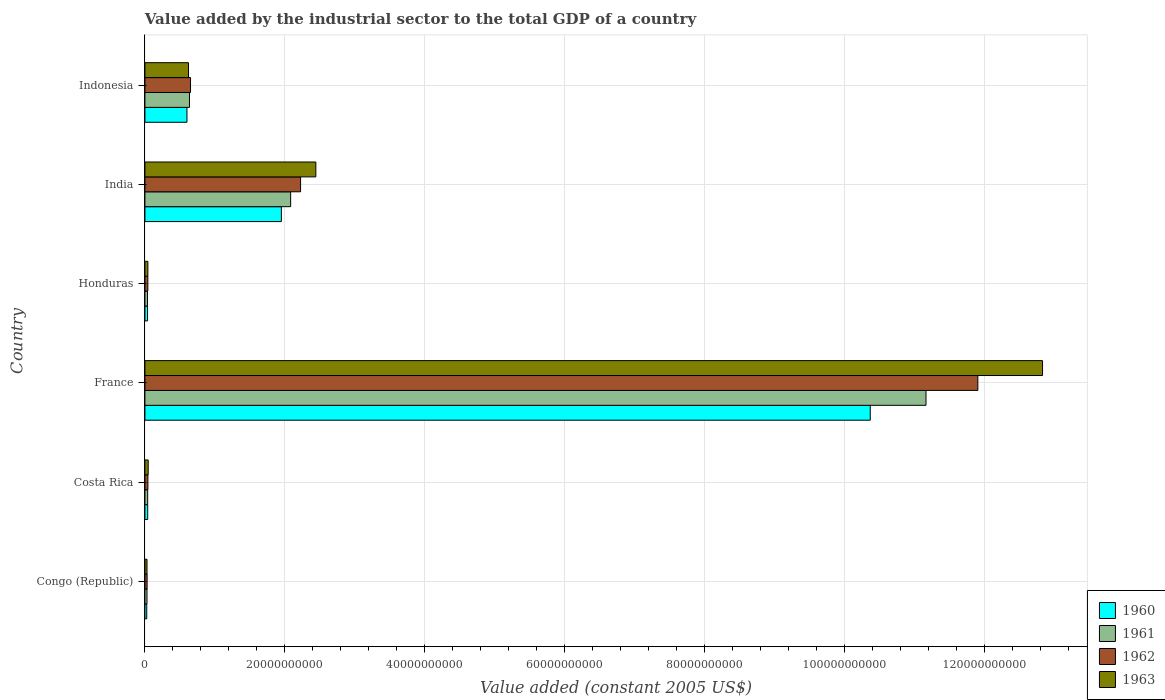How many different coloured bars are there?
Provide a succinct answer. 4. How many groups of bars are there?
Ensure brevity in your answer.  6. Are the number of bars per tick equal to the number of legend labels?
Your answer should be compact. Yes. Are the number of bars on each tick of the Y-axis equal?
Keep it short and to the point. Yes. What is the label of the 3rd group of bars from the top?
Provide a succinct answer. Honduras. What is the value added by the industrial sector in 1963 in France?
Offer a very short reply. 1.28e+11. Across all countries, what is the maximum value added by the industrial sector in 1961?
Ensure brevity in your answer.  1.12e+11. Across all countries, what is the minimum value added by the industrial sector in 1962?
Make the answer very short. 3.12e+08. In which country was the value added by the industrial sector in 1960 maximum?
Make the answer very short. France. In which country was the value added by the industrial sector in 1963 minimum?
Offer a terse response. Congo (Republic). What is the total value added by the industrial sector in 1960 in the graph?
Keep it short and to the point. 1.30e+11. What is the difference between the value added by the industrial sector in 1963 in India and that in Indonesia?
Provide a short and direct response. 1.82e+1. What is the difference between the value added by the industrial sector in 1961 in France and the value added by the industrial sector in 1960 in Indonesia?
Your answer should be very brief. 1.06e+11. What is the average value added by the industrial sector in 1962 per country?
Provide a short and direct response. 2.48e+1. What is the difference between the value added by the industrial sector in 1961 and value added by the industrial sector in 1962 in Honduras?
Provide a succinct answer. -5.00e+07. In how many countries, is the value added by the industrial sector in 1962 greater than 36000000000 US$?
Give a very brief answer. 1. What is the ratio of the value added by the industrial sector in 1963 in Congo (Republic) to that in Honduras?
Provide a short and direct response. 0.71. Is the value added by the industrial sector in 1962 in Congo (Republic) less than that in Costa Rica?
Make the answer very short. Yes. What is the difference between the highest and the second highest value added by the industrial sector in 1963?
Provide a short and direct response. 1.04e+11. What is the difference between the highest and the lowest value added by the industrial sector in 1961?
Keep it short and to the point. 1.11e+11. Is the sum of the value added by the industrial sector in 1961 in France and India greater than the maximum value added by the industrial sector in 1960 across all countries?
Your answer should be very brief. Yes. How many bars are there?
Your response must be concise. 24. How many countries are there in the graph?
Provide a short and direct response. 6. Where does the legend appear in the graph?
Your answer should be very brief. Bottom right. How many legend labels are there?
Keep it short and to the point. 4. How are the legend labels stacked?
Keep it short and to the point. Vertical. What is the title of the graph?
Your answer should be very brief. Value added by the industrial sector to the total GDP of a country. Does "1962" appear as one of the legend labels in the graph?
Your answer should be compact. Yes. What is the label or title of the X-axis?
Your answer should be compact. Value added (constant 2005 US$). What is the Value added (constant 2005 US$) of 1960 in Congo (Republic)?
Make the answer very short. 2.61e+08. What is the Value added (constant 2005 US$) of 1961 in Congo (Republic)?
Make the answer very short. 2.98e+08. What is the Value added (constant 2005 US$) in 1962 in Congo (Republic)?
Keep it short and to the point. 3.12e+08. What is the Value added (constant 2005 US$) of 1963 in Congo (Republic)?
Make the answer very short. 3.00e+08. What is the Value added (constant 2005 US$) in 1960 in Costa Rica?
Offer a very short reply. 3.98e+08. What is the Value added (constant 2005 US$) in 1961 in Costa Rica?
Your answer should be compact. 3.94e+08. What is the Value added (constant 2005 US$) in 1962 in Costa Rica?
Provide a short and direct response. 4.27e+08. What is the Value added (constant 2005 US$) in 1963 in Costa Rica?
Make the answer very short. 4.68e+08. What is the Value added (constant 2005 US$) of 1960 in France?
Offer a terse response. 1.04e+11. What is the Value added (constant 2005 US$) of 1961 in France?
Give a very brief answer. 1.12e+11. What is the Value added (constant 2005 US$) of 1962 in France?
Offer a terse response. 1.19e+11. What is the Value added (constant 2005 US$) in 1963 in France?
Keep it short and to the point. 1.28e+11. What is the Value added (constant 2005 US$) of 1960 in Honduras?
Your answer should be compact. 3.75e+08. What is the Value added (constant 2005 US$) in 1961 in Honduras?
Provide a succinct answer. 3.66e+08. What is the Value added (constant 2005 US$) in 1962 in Honduras?
Provide a succinct answer. 4.16e+08. What is the Value added (constant 2005 US$) of 1963 in Honduras?
Give a very brief answer. 4.23e+08. What is the Value added (constant 2005 US$) of 1960 in India?
Your answer should be very brief. 1.95e+1. What is the Value added (constant 2005 US$) of 1961 in India?
Ensure brevity in your answer.  2.08e+1. What is the Value added (constant 2005 US$) in 1962 in India?
Offer a terse response. 2.22e+1. What is the Value added (constant 2005 US$) of 1963 in India?
Give a very brief answer. 2.44e+1. What is the Value added (constant 2005 US$) of 1960 in Indonesia?
Provide a short and direct response. 6.01e+09. What is the Value added (constant 2005 US$) in 1961 in Indonesia?
Your response must be concise. 6.37e+09. What is the Value added (constant 2005 US$) in 1962 in Indonesia?
Make the answer very short. 6.52e+09. What is the Value added (constant 2005 US$) of 1963 in Indonesia?
Offer a terse response. 6.23e+09. Across all countries, what is the maximum Value added (constant 2005 US$) in 1960?
Keep it short and to the point. 1.04e+11. Across all countries, what is the maximum Value added (constant 2005 US$) of 1961?
Offer a very short reply. 1.12e+11. Across all countries, what is the maximum Value added (constant 2005 US$) of 1962?
Keep it short and to the point. 1.19e+11. Across all countries, what is the maximum Value added (constant 2005 US$) of 1963?
Provide a succinct answer. 1.28e+11. Across all countries, what is the minimum Value added (constant 2005 US$) in 1960?
Offer a very short reply. 2.61e+08. Across all countries, what is the minimum Value added (constant 2005 US$) of 1961?
Give a very brief answer. 2.98e+08. Across all countries, what is the minimum Value added (constant 2005 US$) in 1962?
Offer a terse response. 3.12e+08. Across all countries, what is the minimum Value added (constant 2005 US$) of 1963?
Offer a very short reply. 3.00e+08. What is the total Value added (constant 2005 US$) in 1960 in the graph?
Provide a succinct answer. 1.30e+11. What is the total Value added (constant 2005 US$) in 1961 in the graph?
Provide a short and direct response. 1.40e+11. What is the total Value added (constant 2005 US$) of 1962 in the graph?
Give a very brief answer. 1.49e+11. What is the total Value added (constant 2005 US$) of 1963 in the graph?
Offer a terse response. 1.60e+11. What is the difference between the Value added (constant 2005 US$) of 1960 in Congo (Republic) and that in Costa Rica?
Provide a short and direct response. -1.36e+08. What is the difference between the Value added (constant 2005 US$) in 1961 in Congo (Republic) and that in Costa Rica?
Your answer should be compact. -9.59e+07. What is the difference between the Value added (constant 2005 US$) of 1962 in Congo (Republic) and that in Costa Rica?
Offer a very short reply. -1.14e+08. What is the difference between the Value added (constant 2005 US$) in 1963 in Congo (Republic) and that in Costa Rica?
Provide a succinct answer. -1.68e+08. What is the difference between the Value added (constant 2005 US$) in 1960 in Congo (Republic) and that in France?
Keep it short and to the point. -1.03e+11. What is the difference between the Value added (constant 2005 US$) of 1961 in Congo (Republic) and that in France?
Give a very brief answer. -1.11e+11. What is the difference between the Value added (constant 2005 US$) in 1962 in Congo (Republic) and that in France?
Offer a terse response. -1.19e+11. What is the difference between the Value added (constant 2005 US$) in 1963 in Congo (Republic) and that in France?
Make the answer very short. -1.28e+11. What is the difference between the Value added (constant 2005 US$) in 1960 in Congo (Republic) and that in Honduras?
Your answer should be very brief. -1.14e+08. What is the difference between the Value added (constant 2005 US$) of 1961 in Congo (Republic) and that in Honduras?
Give a very brief answer. -6.81e+07. What is the difference between the Value added (constant 2005 US$) in 1962 in Congo (Republic) and that in Honduras?
Your response must be concise. -1.03e+08. What is the difference between the Value added (constant 2005 US$) of 1963 in Congo (Republic) and that in Honduras?
Keep it short and to the point. -1.23e+08. What is the difference between the Value added (constant 2005 US$) of 1960 in Congo (Republic) and that in India?
Provide a succinct answer. -1.92e+1. What is the difference between the Value added (constant 2005 US$) of 1961 in Congo (Republic) and that in India?
Give a very brief answer. -2.05e+1. What is the difference between the Value added (constant 2005 US$) of 1962 in Congo (Republic) and that in India?
Provide a succinct answer. -2.19e+1. What is the difference between the Value added (constant 2005 US$) of 1963 in Congo (Republic) and that in India?
Keep it short and to the point. -2.41e+1. What is the difference between the Value added (constant 2005 US$) of 1960 in Congo (Republic) and that in Indonesia?
Provide a succinct answer. -5.75e+09. What is the difference between the Value added (constant 2005 US$) in 1961 in Congo (Republic) and that in Indonesia?
Ensure brevity in your answer.  -6.07e+09. What is the difference between the Value added (constant 2005 US$) in 1962 in Congo (Republic) and that in Indonesia?
Provide a short and direct response. -6.20e+09. What is the difference between the Value added (constant 2005 US$) in 1963 in Congo (Republic) and that in Indonesia?
Give a very brief answer. -5.93e+09. What is the difference between the Value added (constant 2005 US$) of 1960 in Costa Rica and that in France?
Keep it short and to the point. -1.03e+11. What is the difference between the Value added (constant 2005 US$) of 1961 in Costa Rica and that in France?
Your answer should be very brief. -1.11e+11. What is the difference between the Value added (constant 2005 US$) in 1962 in Costa Rica and that in France?
Ensure brevity in your answer.  -1.19e+11. What is the difference between the Value added (constant 2005 US$) of 1963 in Costa Rica and that in France?
Offer a very short reply. -1.28e+11. What is the difference between the Value added (constant 2005 US$) of 1960 in Costa Rica and that in Honduras?
Your answer should be compact. 2.26e+07. What is the difference between the Value added (constant 2005 US$) of 1961 in Costa Rica and that in Honduras?
Offer a very short reply. 2.78e+07. What is the difference between the Value added (constant 2005 US$) in 1962 in Costa Rica and that in Honduras?
Your answer should be very brief. 1.10e+07. What is the difference between the Value added (constant 2005 US$) of 1963 in Costa Rica and that in Honduras?
Your response must be concise. 4.49e+07. What is the difference between the Value added (constant 2005 US$) of 1960 in Costa Rica and that in India?
Make the answer very short. -1.91e+1. What is the difference between the Value added (constant 2005 US$) in 1961 in Costa Rica and that in India?
Provide a succinct answer. -2.04e+1. What is the difference between the Value added (constant 2005 US$) of 1962 in Costa Rica and that in India?
Make the answer very short. -2.18e+1. What is the difference between the Value added (constant 2005 US$) in 1963 in Costa Rica and that in India?
Provide a short and direct response. -2.40e+1. What is the difference between the Value added (constant 2005 US$) of 1960 in Costa Rica and that in Indonesia?
Provide a short and direct response. -5.61e+09. What is the difference between the Value added (constant 2005 US$) in 1961 in Costa Rica and that in Indonesia?
Provide a succinct answer. -5.97e+09. What is the difference between the Value added (constant 2005 US$) in 1962 in Costa Rica and that in Indonesia?
Your response must be concise. -6.09e+09. What is the difference between the Value added (constant 2005 US$) of 1963 in Costa Rica and that in Indonesia?
Provide a succinct answer. -5.76e+09. What is the difference between the Value added (constant 2005 US$) of 1960 in France and that in Honduras?
Offer a very short reply. 1.03e+11. What is the difference between the Value added (constant 2005 US$) in 1961 in France and that in Honduras?
Provide a short and direct response. 1.11e+11. What is the difference between the Value added (constant 2005 US$) in 1962 in France and that in Honduras?
Offer a terse response. 1.19e+11. What is the difference between the Value added (constant 2005 US$) in 1963 in France and that in Honduras?
Offer a very short reply. 1.28e+11. What is the difference between the Value added (constant 2005 US$) in 1960 in France and that in India?
Offer a very short reply. 8.42e+1. What is the difference between the Value added (constant 2005 US$) of 1961 in France and that in India?
Ensure brevity in your answer.  9.08e+1. What is the difference between the Value added (constant 2005 US$) of 1962 in France and that in India?
Offer a very short reply. 9.68e+1. What is the difference between the Value added (constant 2005 US$) of 1963 in France and that in India?
Provide a succinct answer. 1.04e+11. What is the difference between the Value added (constant 2005 US$) in 1960 in France and that in Indonesia?
Make the answer very short. 9.77e+1. What is the difference between the Value added (constant 2005 US$) in 1961 in France and that in Indonesia?
Provide a short and direct response. 1.05e+11. What is the difference between the Value added (constant 2005 US$) of 1962 in France and that in Indonesia?
Give a very brief answer. 1.13e+11. What is the difference between the Value added (constant 2005 US$) in 1963 in France and that in Indonesia?
Ensure brevity in your answer.  1.22e+11. What is the difference between the Value added (constant 2005 US$) in 1960 in Honduras and that in India?
Offer a terse response. -1.91e+1. What is the difference between the Value added (constant 2005 US$) of 1961 in Honduras and that in India?
Give a very brief answer. -2.05e+1. What is the difference between the Value added (constant 2005 US$) in 1962 in Honduras and that in India?
Your response must be concise. -2.18e+1. What is the difference between the Value added (constant 2005 US$) in 1963 in Honduras and that in India?
Your answer should be very brief. -2.40e+1. What is the difference between the Value added (constant 2005 US$) in 1960 in Honduras and that in Indonesia?
Give a very brief answer. -5.63e+09. What is the difference between the Value added (constant 2005 US$) of 1961 in Honduras and that in Indonesia?
Make the answer very short. -6.00e+09. What is the difference between the Value added (constant 2005 US$) of 1962 in Honduras and that in Indonesia?
Make the answer very short. -6.10e+09. What is the difference between the Value added (constant 2005 US$) in 1963 in Honduras and that in Indonesia?
Ensure brevity in your answer.  -5.81e+09. What is the difference between the Value added (constant 2005 US$) in 1960 in India and that in Indonesia?
Your response must be concise. 1.35e+1. What is the difference between the Value added (constant 2005 US$) of 1961 in India and that in Indonesia?
Offer a very short reply. 1.45e+1. What is the difference between the Value added (constant 2005 US$) of 1962 in India and that in Indonesia?
Make the answer very short. 1.57e+1. What is the difference between the Value added (constant 2005 US$) in 1963 in India and that in Indonesia?
Provide a short and direct response. 1.82e+1. What is the difference between the Value added (constant 2005 US$) of 1960 in Congo (Republic) and the Value added (constant 2005 US$) of 1961 in Costa Rica?
Keep it short and to the point. -1.32e+08. What is the difference between the Value added (constant 2005 US$) in 1960 in Congo (Republic) and the Value added (constant 2005 US$) in 1962 in Costa Rica?
Provide a short and direct response. -1.65e+08. What is the difference between the Value added (constant 2005 US$) of 1960 in Congo (Republic) and the Value added (constant 2005 US$) of 1963 in Costa Rica?
Offer a terse response. -2.07e+08. What is the difference between the Value added (constant 2005 US$) in 1961 in Congo (Republic) and the Value added (constant 2005 US$) in 1962 in Costa Rica?
Give a very brief answer. -1.29e+08. What is the difference between the Value added (constant 2005 US$) of 1961 in Congo (Republic) and the Value added (constant 2005 US$) of 1963 in Costa Rica?
Offer a terse response. -1.70e+08. What is the difference between the Value added (constant 2005 US$) of 1962 in Congo (Republic) and the Value added (constant 2005 US$) of 1963 in Costa Rica?
Your response must be concise. -1.56e+08. What is the difference between the Value added (constant 2005 US$) in 1960 in Congo (Republic) and the Value added (constant 2005 US$) in 1961 in France?
Give a very brief answer. -1.11e+11. What is the difference between the Value added (constant 2005 US$) in 1960 in Congo (Republic) and the Value added (constant 2005 US$) in 1962 in France?
Ensure brevity in your answer.  -1.19e+11. What is the difference between the Value added (constant 2005 US$) of 1960 in Congo (Republic) and the Value added (constant 2005 US$) of 1963 in France?
Your answer should be very brief. -1.28e+11. What is the difference between the Value added (constant 2005 US$) in 1961 in Congo (Republic) and the Value added (constant 2005 US$) in 1962 in France?
Your answer should be compact. -1.19e+11. What is the difference between the Value added (constant 2005 US$) in 1961 in Congo (Republic) and the Value added (constant 2005 US$) in 1963 in France?
Your answer should be very brief. -1.28e+11. What is the difference between the Value added (constant 2005 US$) of 1962 in Congo (Republic) and the Value added (constant 2005 US$) of 1963 in France?
Your answer should be very brief. -1.28e+11. What is the difference between the Value added (constant 2005 US$) of 1960 in Congo (Republic) and the Value added (constant 2005 US$) of 1961 in Honduras?
Provide a short and direct response. -1.04e+08. What is the difference between the Value added (constant 2005 US$) in 1960 in Congo (Republic) and the Value added (constant 2005 US$) in 1962 in Honduras?
Provide a succinct answer. -1.54e+08. What is the difference between the Value added (constant 2005 US$) in 1960 in Congo (Republic) and the Value added (constant 2005 US$) in 1963 in Honduras?
Offer a terse response. -1.62e+08. What is the difference between the Value added (constant 2005 US$) of 1961 in Congo (Republic) and the Value added (constant 2005 US$) of 1962 in Honduras?
Provide a short and direct response. -1.18e+08. What is the difference between the Value added (constant 2005 US$) in 1961 in Congo (Republic) and the Value added (constant 2005 US$) in 1963 in Honduras?
Provide a succinct answer. -1.25e+08. What is the difference between the Value added (constant 2005 US$) of 1962 in Congo (Republic) and the Value added (constant 2005 US$) of 1963 in Honduras?
Offer a very short reply. -1.11e+08. What is the difference between the Value added (constant 2005 US$) in 1960 in Congo (Republic) and the Value added (constant 2005 US$) in 1961 in India?
Your answer should be very brief. -2.06e+1. What is the difference between the Value added (constant 2005 US$) in 1960 in Congo (Republic) and the Value added (constant 2005 US$) in 1962 in India?
Keep it short and to the point. -2.20e+1. What is the difference between the Value added (constant 2005 US$) in 1960 in Congo (Republic) and the Value added (constant 2005 US$) in 1963 in India?
Keep it short and to the point. -2.42e+1. What is the difference between the Value added (constant 2005 US$) of 1961 in Congo (Republic) and the Value added (constant 2005 US$) of 1962 in India?
Offer a very short reply. -2.19e+1. What is the difference between the Value added (constant 2005 US$) of 1961 in Congo (Republic) and the Value added (constant 2005 US$) of 1963 in India?
Give a very brief answer. -2.41e+1. What is the difference between the Value added (constant 2005 US$) in 1962 in Congo (Republic) and the Value added (constant 2005 US$) in 1963 in India?
Offer a terse response. -2.41e+1. What is the difference between the Value added (constant 2005 US$) of 1960 in Congo (Republic) and the Value added (constant 2005 US$) of 1961 in Indonesia?
Ensure brevity in your answer.  -6.11e+09. What is the difference between the Value added (constant 2005 US$) in 1960 in Congo (Republic) and the Value added (constant 2005 US$) in 1962 in Indonesia?
Your answer should be very brief. -6.26e+09. What is the difference between the Value added (constant 2005 US$) of 1960 in Congo (Republic) and the Value added (constant 2005 US$) of 1963 in Indonesia?
Your response must be concise. -5.97e+09. What is the difference between the Value added (constant 2005 US$) of 1961 in Congo (Republic) and the Value added (constant 2005 US$) of 1962 in Indonesia?
Offer a very short reply. -6.22e+09. What is the difference between the Value added (constant 2005 US$) in 1961 in Congo (Republic) and the Value added (constant 2005 US$) in 1963 in Indonesia?
Provide a short and direct response. -5.93e+09. What is the difference between the Value added (constant 2005 US$) in 1962 in Congo (Republic) and the Value added (constant 2005 US$) in 1963 in Indonesia?
Your answer should be very brief. -5.92e+09. What is the difference between the Value added (constant 2005 US$) of 1960 in Costa Rica and the Value added (constant 2005 US$) of 1961 in France?
Make the answer very short. -1.11e+11. What is the difference between the Value added (constant 2005 US$) of 1960 in Costa Rica and the Value added (constant 2005 US$) of 1962 in France?
Keep it short and to the point. -1.19e+11. What is the difference between the Value added (constant 2005 US$) of 1960 in Costa Rica and the Value added (constant 2005 US$) of 1963 in France?
Your response must be concise. -1.28e+11. What is the difference between the Value added (constant 2005 US$) of 1961 in Costa Rica and the Value added (constant 2005 US$) of 1962 in France?
Offer a very short reply. -1.19e+11. What is the difference between the Value added (constant 2005 US$) of 1961 in Costa Rica and the Value added (constant 2005 US$) of 1963 in France?
Offer a very short reply. -1.28e+11. What is the difference between the Value added (constant 2005 US$) of 1962 in Costa Rica and the Value added (constant 2005 US$) of 1963 in France?
Keep it short and to the point. -1.28e+11. What is the difference between the Value added (constant 2005 US$) of 1960 in Costa Rica and the Value added (constant 2005 US$) of 1961 in Honduras?
Your response must be concise. 3.20e+07. What is the difference between the Value added (constant 2005 US$) of 1960 in Costa Rica and the Value added (constant 2005 US$) of 1962 in Honduras?
Provide a succinct answer. -1.81e+07. What is the difference between the Value added (constant 2005 US$) in 1960 in Costa Rica and the Value added (constant 2005 US$) in 1963 in Honduras?
Ensure brevity in your answer.  -2.52e+07. What is the difference between the Value added (constant 2005 US$) in 1961 in Costa Rica and the Value added (constant 2005 US$) in 1962 in Honduras?
Ensure brevity in your answer.  -2.22e+07. What is the difference between the Value added (constant 2005 US$) of 1961 in Costa Rica and the Value added (constant 2005 US$) of 1963 in Honduras?
Make the answer very short. -2.94e+07. What is the difference between the Value added (constant 2005 US$) of 1962 in Costa Rica and the Value added (constant 2005 US$) of 1963 in Honduras?
Provide a succinct answer. 3.81e+06. What is the difference between the Value added (constant 2005 US$) of 1960 in Costa Rica and the Value added (constant 2005 US$) of 1961 in India?
Your answer should be very brief. -2.04e+1. What is the difference between the Value added (constant 2005 US$) in 1960 in Costa Rica and the Value added (constant 2005 US$) in 1962 in India?
Your response must be concise. -2.18e+1. What is the difference between the Value added (constant 2005 US$) in 1960 in Costa Rica and the Value added (constant 2005 US$) in 1963 in India?
Offer a terse response. -2.40e+1. What is the difference between the Value added (constant 2005 US$) of 1961 in Costa Rica and the Value added (constant 2005 US$) of 1962 in India?
Your answer should be compact. -2.19e+1. What is the difference between the Value added (constant 2005 US$) of 1961 in Costa Rica and the Value added (constant 2005 US$) of 1963 in India?
Keep it short and to the point. -2.40e+1. What is the difference between the Value added (constant 2005 US$) in 1962 in Costa Rica and the Value added (constant 2005 US$) in 1963 in India?
Your answer should be compact. -2.40e+1. What is the difference between the Value added (constant 2005 US$) of 1960 in Costa Rica and the Value added (constant 2005 US$) of 1961 in Indonesia?
Give a very brief answer. -5.97e+09. What is the difference between the Value added (constant 2005 US$) of 1960 in Costa Rica and the Value added (constant 2005 US$) of 1962 in Indonesia?
Give a very brief answer. -6.12e+09. What is the difference between the Value added (constant 2005 US$) in 1960 in Costa Rica and the Value added (constant 2005 US$) in 1963 in Indonesia?
Offer a terse response. -5.83e+09. What is the difference between the Value added (constant 2005 US$) in 1961 in Costa Rica and the Value added (constant 2005 US$) in 1962 in Indonesia?
Your answer should be very brief. -6.12e+09. What is the difference between the Value added (constant 2005 US$) in 1961 in Costa Rica and the Value added (constant 2005 US$) in 1963 in Indonesia?
Offer a terse response. -5.84e+09. What is the difference between the Value added (constant 2005 US$) in 1962 in Costa Rica and the Value added (constant 2005 US$) in 1963 in Indonesia?
Your answer should be very brief. -5.80e+09. What is the difference between the Value added (constant 2005 US$) of 1960 in France and the Value added (constant 2005 US$) of 1961 in Honduras?
Your response must be concise. 1.03e+11. What is the difference between the Value added (constant 2005 US$) in 1960 in France and the Value added (constant 2005 US$) in 1962 in Honduras?
Your response must be concise. 1.03e+11. What is the difference between the Value added (constant 2005 US$) in 1960 in France and the Value added (constant 2005 US$) in 1963 in Honduras?
Your response must be concise. 1.03e+11. What is the difference between the Value added (constant 2005 US$) of 1961 in France and the Value added (constant 2005 US$) of 1962 in Honduras?
Provide a short and direct response. 1.11e+11. What is the difference between the Value added (constant 2005 US$) in 1961 in France and the Value added (constant 2005 US$) in 1963 in Honduras?
Your response must be concise. 1.11e+11. What is the difference between the Value added (constant 2005 US$) in 1962 in France and the Value added (constant 2005 US$) in 1963 in Honduras?
Your answer should be compact. 1.19e+11. What is the difference between the Value added (constant 2005 US$) in 1960 in France and the Value added (constant 2005 US$) in 1961 in India?
Give a very brief answer. 8.28e+1. What is the difference between the Value added (constant 2005 US$) in 1960 in France and the Value added (constant 2005 US$) in 1962 in India?
Make the answer very short. 8.14e+1. What is the difference between the Value added (constant 2005 US$) of 1960 in France and the Value added (constant 2005 US$) of 1963 in India?
Your answer should be very brief. 7.92e+1. What is the difference between the Value added (constant 2005 US$) in 1961 in France and the Value added (constant 2005 US$) in 1962 in India?
Keep it short and to the point. 8.94e+1. What is the difference between the Value added (constant 2005 US$) of 1961 in France and the Value added (constant 2005 US$) of 1963 in India?
Make the answer very short. 8.72e+1. What is the difference between the Value added (constant 2005 US$) of 1962 in France and the Value added (constant 2005 US$) of 1963 in India?
Offer a terse response. 9.46e+1. What is the difference between the Value added (constant 2005 US$) in 1960 in France and the Value added (constant 2005 US$) in 1961 in Indonesia?
Provide a succinct answer. 9.73e+1. What is the difference between the Value added (constant 2005 US$) of 1960 in France and the Value added (constant 2005 US$) of 1962 in Indonesia?
Offer a very short reply. 9.71e+1. What is the difference between the Value added (constant 2005 US$) in 1960 in France and the Value added (constant 2005 US$) in 1963 in Indonesia?
Your response must be concise. 9.74e+1. What is the difference between the Value added (constant 2005 US$) of 1961 in France and the Value added (constant 2005 US$) of 1962 in Indonesia?
Make the answer very short. 1.05e+11. What is the difference between the Value added (constant 2005 US$) of 1961 in France and the Value added (constant 2005 US$) of 1963 in Indonesia?
Your response must be concise. 1.05e+11. What is the difference between the Value added (constant 2005 US$) of 1962 in France and the Value added (constant 2005 US$) of 1963 in Indonesia?
Offer a terse response. 1.13e+11. What is the difference between the Value added (constant 2005 US$) in 1960 in Honduras and the Value added (constant 2005 US$) in 1961 in India?
Provide a short and direct response. -2.05e+1. What is the difference between the Value added (constant 2005 US$) of 1960 in Honduras and the Value added (constant 2005 US$) of 1962 in India?
Your answer should be compact. -2.19e+1. What is the difference between the Value added (constant 2005 US$) in 1960 in Honduras and the Value added (constant 2005 US$) in 1963 in India?
Offer a very short reply. -2.41e+1. What is the difference between the Value added (constant 2005 US$) in 1961 in Honduras and the Value added (constant 2005 US$) in 1962 in India?
Provide a succinct answer. -2.19e+1. What is the difference between the Value added (constant 2005 US$) of 1961 in Honduras and the Value added (constant 2005 US$) of 1963 in India?
Offer a terse response. -2.41e+1. What is the difference between the Value added (constant 2005 US$) of 1962 in Honduras and the Value added (constant 2005 US$) of 1963 in India?
Provide a succinct answer. -2.40e+1. What is the difference between the Value added (constant 2005 US$) of 1960 in Honduras and the Value added (constant 2005 US$) of 1961 in Indonesia?
Your answer should be compact. -5.99e+09. What is the difference between the Value added (constant 2005 US$) of 1960 in Honduras and the Value added (constant 2005 US$) of 1962 in Indonesia?
Ensure brevity in your answer.  -6.14e+09. What is the difference between the Value added (constant 2005 US$) in 1960 in Honduras and the Value added (constant 2005 US$) in 1963 in Indonesia?
Provide a succinct answer. -5.85e+09. What is the difference between the Value added (constant 2005 US$) of 1961 in Honduras and the Value added (constant 2005 US$) of 1962 in Indonesia?
Provide a short and direct response. -6.15e+09. What is the difference between the Value added (constant 2005 US$) in 1961 in Honduras and the Value added (constant 2005 US$) in 1963 in Indonesia?
Your answer should be compact. -5.86e+09. What is the difference between the Value added (constant 2005 US$) of 1962 in Honduras and the Value added (constant 2005 US$) of 1963 in Indonesia?
Your answer should be compact. -5.81e+09. What is the difference between the Value added (constant 2005 US$) in 1960 in India and the Value added (constant 2005 US$) in 1961 in Indonesia?
Keep it short and to the point. 1.31e+1. What is the difference between the Value added (constant 2005 US$) in 1960 in India and the Value added (constant 2005 US$) in 1962 in Indonesia?
Your response must be concise. 1.30e+1. What is the difference between the Value added (constant 2005 US$) in 1960 in India and the Value added (constant 2005 US$) in 1963 in Indonesia?
Your response must be concise. 1.33e+1. What is the difference between the Value added (constant 2005 US$) in 1961 in India and the Value added (constant 2005 US$) in 1962 in Indonesia?
Provide a succinct answer. 1.43e+1. What is the difference between the Value added (constant 2005 US$) in 1961 in India and the Value added (constant 2005 US$) in 1963 in Indonesia?
Keep it short and to the point. 1.46e+1. What is the difference between the Value added (constant 2005 US$) of 1962 in India and the Value added (constant 2005 US$) of 1963 in Indonesia?
Give a very brief answer. 1.60e+1. What is the average Value added (constant 2005 US$) in 1960 per country?
Make the answer very short. 2.17e+1. What is the average Value added (constant 2005 US$) in 1961 per country?
Provide a short and direct response. 2.33e+1. What is the average Value added (constant 2005 US$) in 1962 per country?
Give a very brief answer. 2.48e+1. What is the average Value added (constant 2005 US$) of 1963 per country?
Provide a short and direct response. 2.67e+1. What is the difference between the Value added (constant 2005 US$) of 1960 and Value added (constant 2005 US$) of 1961 in Congo (Republic)?
Keep it short and to the point. -3.63e+07. What is the difference between the Value added (constant 2005 US$) of 1960 and Value added (constant 2005 US$) of 1962 in Congo (Republic)?
Provide a succinct answer. -5.10e+07. What is the difference between the Value added (constant 2005 US$) in 1960 and Value added (constant 2005 US$) in 1963 in Congo (Republic)?
Offer a terse response. -3.84e+07. What is the difference between the Value added (constant 2005 US$) of 1961 and Value added (constant 2005 US$) of 1962 in Congo (Republic)?
Your answer should be very brief. -1.47e+07. What is the difference between the Value added (constant 2005 US$) in 1961 and Value added (constant 2005 US$) in 1963 in Congo (Republic)?
Keep it short and to the point. -2.10e+06. What is the difference between the Value added (constant 2005 US$) in 1962 and Value added (constant 2005 US$) in 1963 in Congo (Republic)?
Your response must be concise. 1.26e+07. What is the difference between the Value added (constant 2005 US$) of 1960 and Value added (constant 2005 US$) of 1961 in Costa Rica?
Ensure brevity in your answer.  4.19e+06. What is the difference between the Value added (constant 2005 US$) of 1960 and Value added (constant 2005 US$) of 1962 in Costa Rica?
Your answer should be compact. -2.91e+07. What is the difference between the Value added (constant 2005 US$) in 1960 and Value added (constant 2005 US$) in 1963 in Costa Rica?
Offer a very short reply. -7.01e+07. What is the difference between the Value added (constant 2005 US$) of 1961 and Value added (constant 2005 US$) of 1962 in Costa Rica?
Offer a very short reply. -3.32e+07. What is the difference between the Value added (constant 2005 US$) of 1961 and Value added (constant 2005 US$) of 1963 in Costa Rica?
Keep it short and to the point. -7.43e+07. What is the difference between the Value added (constant 2005 US$) of 1962 and Value added (constant 2005 US$) of 1963 in Costa Rica?
Give a very brief answer. -4.11e+07. What is the difference between the Value added (constant 2005 US$) in 1960 and Value added (constant 2005 US$) in 1961 in France?
Your answer should be compact. -7.97e+09. What is the difference between the Value added (constant 2005 US$) of 1960 and Value added (constant 2005 US$) of 1962 in France?
Your answer should be compact. -1.54e+1. What is the difference between the Value added (constant 2005 US$) of 1960 and Value added (constant 2005 US$) of 1963 in France?
Your answer should be very brief. -2.46e+1. What is the difference between the Value added (constant 2005 US$) of 1961 and Value added (constant 2005 US$) of 1962 in France?
Your response must be concise. -7.41e+09. What is the difference between the Value added (constant 2005 US$) in 1961 and Value added (constant 2005 US$) in 1963 in France?
Ensure brevity in your answer.  -1.67e+1. What is the difference between the Value added (constant 2005 US$) in 1962 and Value added (constant 2005 US$) in 1963 in France?
Offer a terse response. -9.25e+09. What is the difference between the Value added (constant 2005 US$) in 1960 and Value added (constant 2005 US$) in 1961 in Honduras?
Give a very brief answer. 9.37e+06. What is the difference between the Value added (constant 2005 US$) in 1960 and Value added (constant 2005 US$) in 1962 in Honduras?
Provide a succinct answer. -4.07e+07. What is the difference between the Value added (constant 2005 US$) in 1960 and Value added (constant 2005 US$) in 1963 in Honduras?
Make the answer very short. -4.79e+07. What is the difference between the Value added (constant 2005 US$) in 1961 and Value added (constant 2005 US$) in 1962 in Honduras?
Your answer should be compact. -5.00e+07. What is the difference between the Value added (constant 2005 US$) of 1961 and Value added (constant 2005 US$) of 1963 in Honduras?
Make the answer very short. -5.72e+07. What is the difference between the Value added (constant 2005 US$) of 1962 and Value added (constant 2005 US$) of 1963 in Honduras?
Your response must be concise. -7.19e+06. What is the difference between the Value added (constant 2005 US$) of 1960 and Value added (constant 2005 US$) of 1961 in India?
Ensure brevity in your answer.  -1.32e+09. What is the difference between the Value added (constant 2005 US$) of 1960 and Value added (constant 2005 US$) of 1962 in India?
Make the answer very short. -2.74e+09. What is the difference between the Value added (constant 2005 US$) in 1960 and Value added (constant 2005 US$) in 1963 in India?
Provide a succinct answer. -4.92e+09. What is the difference between the Value added (constant 2005 US$) in 1961 and Value added (constant 2005 US$) in 1962 in India?
Your answer should be compact. -1.42e+09. What is the difference between the Value added (constant 2005 US$) in 1961 and Value added (constant 2005 US$) in 1963 in India?
Give a very brief answer. -3.60e+09. What is the difference between the Value added (constant 2005 US$) in 1962 and Value added (constant 2005 US$) in 1963 in India?
Make the answer very short. -2.18e+09. What is the difference between the Value added (constant 2005 US$) in 1960 and Value added (constant 2005 US$) in 1961 in Indonesia?
Offer a very short reply. -3.60e+08. What is the difference between the Value added (constant 2005 US$) of 1960 and Value added (constant 2005 US$) of 1962 in Indonesia?
Offer a very short reply. -5.10e+08. What is the difference between the Value added (constant 2005 US$) of 1960 and Value added (constant 2005 US$) of 1963 in Indonesia?
Keep it short and to the point. -2.22e+08. What is the difference between the Value added (constant 2005 US$) in 1961 and Value added (constant 2005 US$) in 1962 in Indonesia?
Keep it short and to the point. -1.50e+08. What is the difference between the Value added (constant 2005 US$) in 1961 and Value added (constant 2005 US$) in 1963 in Indonesia?
Offer a very short reply. 1.38e+08. What is the difference between the Value added (constant 2005 US$) of 1962 and Value added (constant 2005 US$) of 1963 in Indonesia?
Provide a short and direct response. 2.88e+08. What is the ratio of the Value added (constant 2005 US$) of 1960 in Congo (Republic) to that in Costa Rica?
Keep it short and to the point. 0.66. What is the ratio of the Value added (constant 2005 US$) in 1961 in Congo (Republic) to that in Costa Rica?
Your answer should be very brief. 0.76. What is the ratio of the Value added (constant 2005 US$) of 1962 in Congo (Republic) to that in Costa Rica?
Provide a succinct answer. 0.73. What is the ratio of the Value added (constant 2005 US$) of 1963 in Congo (Republic) to that in Costa Rica?
Your response must be concise. 0.64. What is the ratio of the Value added (constant 2005 US$) in 1960 in Congo (Republic) to that in France?
Your answer should be compact. 0. What is the ratio of the Value added (constant 2005 US$) in 1961 in Congo (Republic) to that in France?
Give a very brief answer. 0. What is the ratio of the Value added (constant 2005 US$) of 1962 in Congo (Republic) to that in France?
Your response must be concise. 0. What is the ratio of the Value added (constant 2005 US$) of 1963 in Congo (Republic) to that in France?
Ensure brevity in your answer.  0. What is the ratio of the Value added (constant 2005 US$) of 1960 in Congo (Republic) to that in Honduras?
Offer a terse response. 0.7. What is the ratio of the Value added (constant 2005 US$) of 1961 in Congo (Republic) to that in Honduras?
Give a very brief answer. 0.81. What is the ratio of the Value added (constant 2005 US$) in 1962 in Congo (Republic) to that in Honduras?
Keep it short and to the point. 0.75. What is the ratio of the Value added (constant 2005 US$) of 1963 in Congo (Republic) to that in Honduras?
Ensure brevity in your answer.  0.71. What is the ratio of the Value added (constant 2005 US$) of 1960 in Congo (Republic) to that in India?
Keep it short and to the point. 0.01. What is the ratio of the Value added (constant 2005 US$) of 1961 in Congo (Republic) to that in India?
Make the answer very short. 0.01. What is the ratio of the Value added (constant 2005 US$) in 1962 in Congo (Republic) to that in India?
Ensure brevity in your answer.  0.01. What is the ratio of the Value added (constant 2005 US$) in 1963 in Congo (Republic) to that in India?
Your response must be concise. 0.01. What is the ratio of the Value added (constant 2005 US$) in 1960 in Congo (Republic) to that in Indonesia?
Keep it short and to the point. 0.04. What is the ratio of the Value added (constant 2005 US$) of 1961 in Congo (Republic) to that in Indonesia?
Your answer should be very brief. 0.05. What is the ratio of the Value added (constant 2005 US$) in 1962 in Congo (Republic) to that in Indonesia?
Your answer should be compact. 0.05. What is the ratio of the Value added (constant 2005 US$) of 1963 in Congo (Republic) to that in Indonesia?
Provide a succinct answer. 0.05. What is the ratio of the Value added (constant 2005 US$) in 1960 in Costa Rica to that in France?
Ensure brevity in your answer.  0. What is the ratio of the Value added (constant 2005 US$) of 1961 in Costa Rica to that in France?
Your answer should be compact. 0. What is the ratio of the Value added (constant 2005 US$) in 1962 in Costa Rica to that in France?
Provide a short and direct response. 0. What is the ratio of the Value added (constant 2005 US$) in 1963 in Costa Rica to that in France?
Keep it short and to the point. 0. What is the ratio of the Value added (constant 2005 US$) of 1960 in Costa Rica to that in Honduras?
Your answer should be very brief. 1.06. What is the ratio of the Value added (constant 2005 US$) in 1961 in Costa Rica to that in Honduras?
Keep it short and to the point. 1.08. What is the ratio of the Value added (constant 2005 US$) of 1962 in Costa Rica to that in Honduras?
Make the answer very short. 1.03. What is the ratio of the Value added (constant 2005 US$) in 1963 in Costa Rica to that in Honduras?
Your response must be concise. 1.11. What is the ratio of the Value added (constant 2005 US$) in 1960 in Costa Rica to that in India?
Offer a very short reply. 0.02. What is the ratio of the Value added (constant 2005 US$) of 1961 in Costa Rica to that in India?
Your answer should be compact. 0.02. What is the ratio of the Value added (constant 2005 US$) in 1962 in Costa Rica to that in India?
Provide a short and direct response. 0.02. What is the ratio of the Value added (constant 2005 US$) of 1963 in Costa Rica to that in India?
Offer a very short reply. 0.02. What is the ratio of the Value added (constant 2005 US$) of 1960 in Costa Rica to that in Indonesia?
Ensure brevity in your answer.  0.07. What is the ratio of the Value added (constant 2005 US$) in 1961 in Costa Rica to that in Indonesia?
Your answer should be compact. 0.06. What is the ratio of the Value added (constant 2005 US$) in 1962 in Costa Rica to that in Indonesia?
Ensure brevity in your answer.  0.07. What is the ratio of the Value added (constant 2005 US$) of 1963 in Costa Rica to that in Indonesia?
Your answer should be compact. 0.08. What is the ratio of the Value added (constant 2005 US$) of 1960 in France to that in Honduras?
Keep it short and to the point. 276.31. What is the ratio of the Value added (constant 2005 US$) in 1961 in France to that in Honduras?
Your answer should be compact. 305.16. What is the ratio of the Value added (constant 2005 US$) of 1962 in France to that in Honduras?
Provide a short and direct response. 286.26. What is the ratio of the Value added (constant 2005 US$) of 1963 in France to that in Honduras?
Your answer should be compact. 303.25. What is the ratio of the Value added (constant 2005 US$) of 1960 in France to that in India?
Make the answer very short. 5.32. What is the ratio of the Value added (constant 2005 US$) in 1961 in France to that in India?
Provide a short and direct response. 5.36. What is the ratio of the Value added (constant 2005 US$) of 1962 in France to that in India?
Keep it short and to the point. 5.35. What is the ratio of the Value added (constant 2005 US$) of 1963 in France to that in India?
Keep it short and to the point. 5.25. What is the ratio of the Value added (constant 2005 US$) in 1960 in France to that in Indonesia?
Provide a short and direct response. 17.26. What is the ratio of the Value added (constant 2005 US$) in 1961 in France to that in Indonesia?
Give a very brief answer. 17.53. What is the ratio of the Value added (constant 2005 US$) of 1962 in France to that in Indonesia?
Provide a succinct answer. 18.27. What is the ratio of the Value added (constant 2005 US$) of 1963 in France to that in Indonesia?
Make the answer very short. 20.59. What is the ratio of the Value added (constant 2005 US$) in 1960 in Honduras to that in India?
Your answer should be compact. 0.02. What is the ratio of the Value added (constant 2005 US$) in 1961 in Honduras to that in India?
Your response must be concise. 0.02. What is the ratio of the Value added (constant 2005 US$) of 1962 in Honduras to that in India?
Your answer should be very brief. 0.02. What is the ratio of the Value added (constant 2005 US$) of 1963 in Honduras to that in India?
Make the answer very short. 0.02. What is the ratio of the Value added (constant 2005 US$) in 1960 in Honduras to that in Indonesia?
Make the answer very short. 0.06. What is the ratio of the Value added (constant 2005 US$) of 1961 in Honduras to that in Indonesia?
Give a very brief answer. 0.06. What is the ratio of the Value added (constant 2005 US$) in 1962 in Honduras to that in Indonesia?
Your answer should be very brief. 0.06. What is the ratio of the Value added (constant 2005 US$) of 1963 in Honduras to that in Indonesia?
Your response must be concise. 0.07. What is the ratio of the Value added (constant 2005 US$) of 1960 in India to that in Indonesia?
Ensure brevity in your answer.  3.25. What is the ratio of the Value added (constant 2005 US$) of 1961 in India to that in Indonesia?
Keep it short and to the point. 3.27. What is the ratio of the Value added (constant 2005 US$) in 1962 in India to that in Indonesia?
Provide a short and direct response. 3.41. What is the ratio of the Value added (constant 2005 US$) of 1963 in India to that in Indonesia?
Your answer should be very brief. 3.92. What is the difference between the highest and the second highest Value added (constant 2005 US$) in 1960?
Keep it short and to the point. 8.42e+1. What is the difference between the highest and the second highest Value added (constant 2005 US$) in 1961?
Your answer should be very brief. 9.08e+1. What is the difference between the highest and the second highest Value added (constant 2005 US$) in 1962?
Provide a short and direct response. 9.68e+1. What is the difference between the highest and the second highest Value added (constant 2005 US$) in 1963?
Offer a very short reply. 1.04e+11. What is the difference between the highest and the lowest Value added (constant 2005 US$) in 1960?
Your response must be concise. 1.03e+11. What is the difference between the highest and the lowest Value added (constant 2005 US$) of 1961?
Provide a succinct answer. 1.11e+11. What is the difference between the highest and the lowest Value added (constant 2005 US$) in 1962?
Your answer should be compact. 1.19e+11. What is the difference between the highest and the lowest Value added (constant 2005 US$) in 1963?
Your answer should be compact. 1.28e+11. 